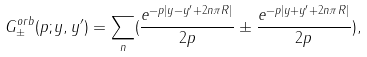<formula> <loc_0><loc_0><loc_500><loc_500>\ G ^ { o r b } _ { \pm } ( p ; y , y ^ { \prime } ) = \sum _ { n } ( \frac { e ^ { - p | y - y ^ { \prime } + 2 n \pi R | } } { 2 p } \pm \frac { e ^ { - p | y + y ^ { \prime } + 2 n \pi R | } } { 2 p } ) ,</formula> 